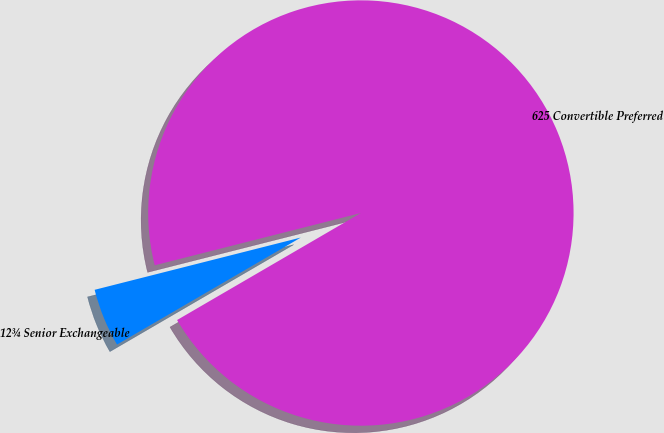<chart> <loc_0><loc_0><loc_500><loc_500><pie_chart><fcel>12¾ Senior Exchangeable<fcel>625 Convertible Preferred<nl><fcel>4.44%<fcel>95.56%<nl></chart> 